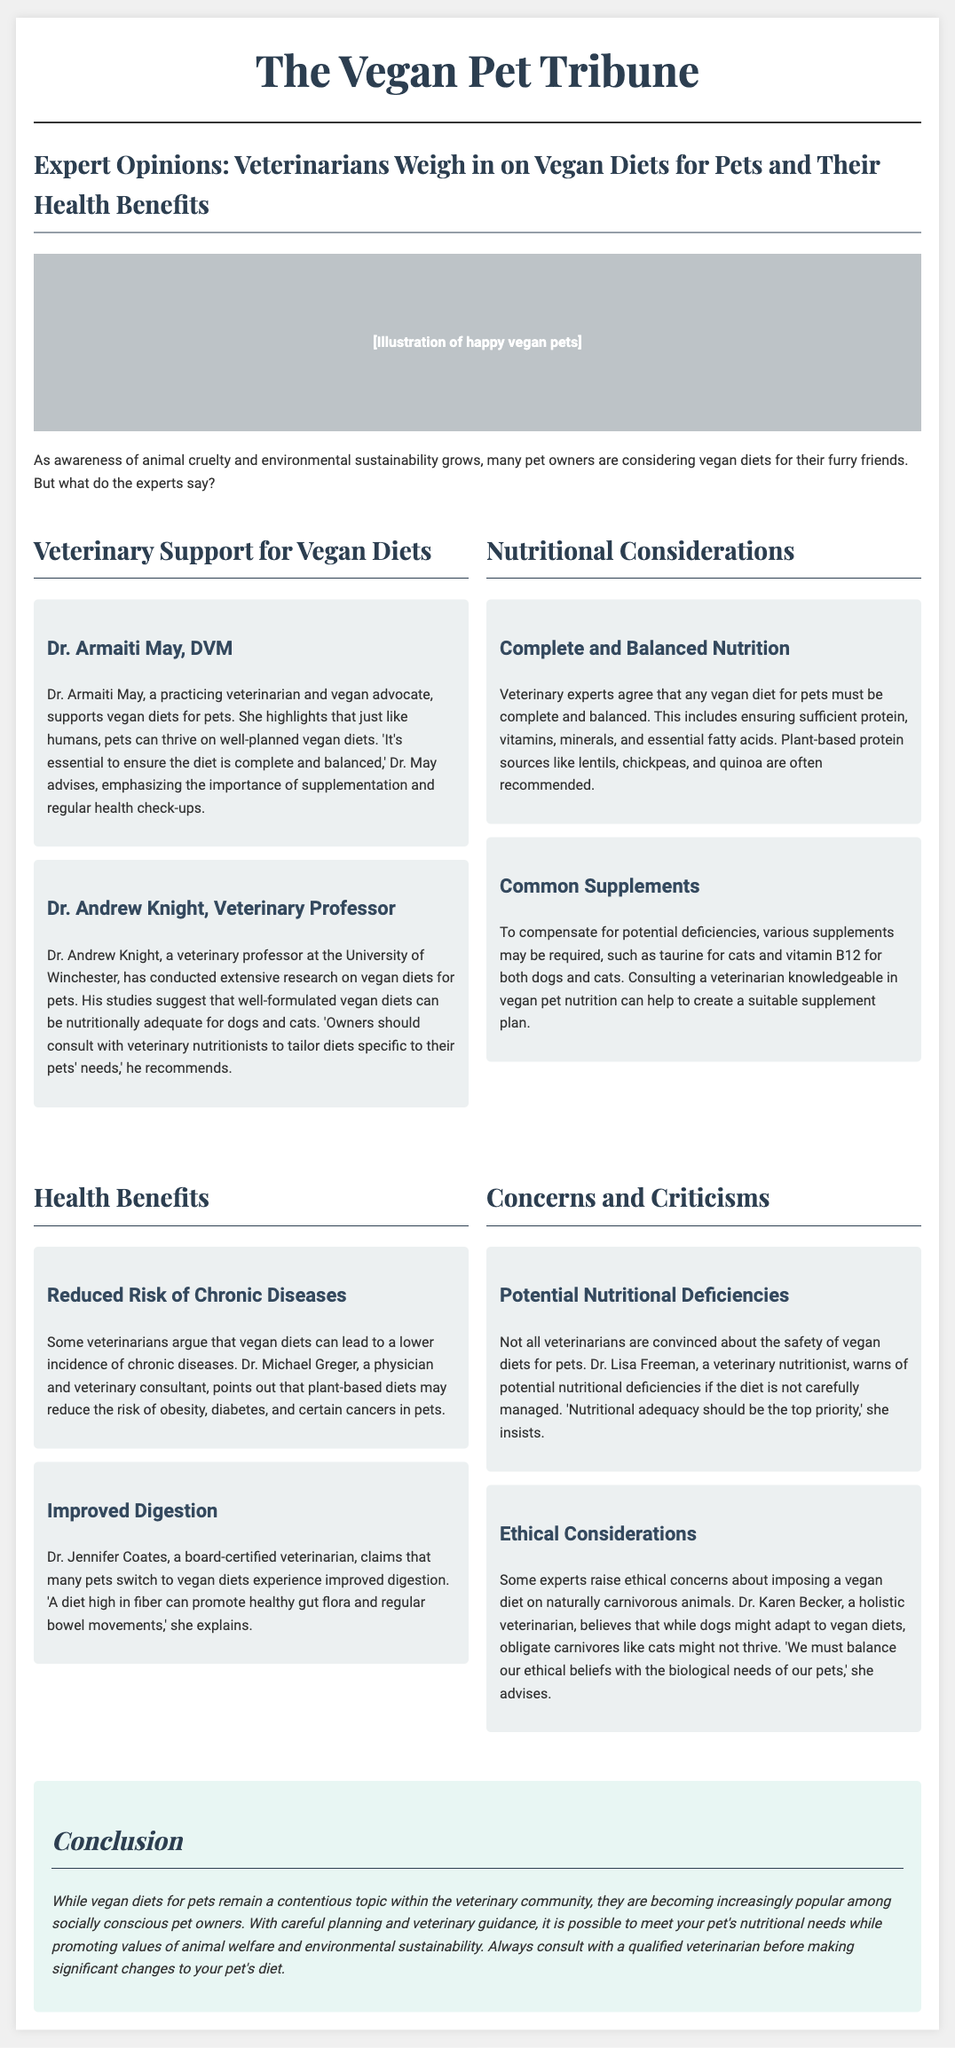What is the name of the veterinarian who supports vegan diets for pets? Dr. Armaiti May is mentioned as a veterinarian and vegan advocate supporting vegan diets for pets.
Answer: Dr. Armaiti May What university is Dr. Andrew Knight associated with? The document states that Dr. Andrew Knight is a veterinary professor at the University of Winchester.
Answer: University of Winchester Which nutrient might be supplemented for cats on a vegan diet? The document mentions that taurine is often a necessary supplement for cats on a vegan diet.
Answer: Taurine What dietary benefit do many pets experience when switching to vegan diets? According to Dr. Jennifer Coates, many pets switching to vegan diets experience improved digestion.
Answer: Improved digestion Who warns about potential nutritional deficiencies in vegan diets for pets? Dr. Lisa Freeman expresses concerns regarding potential nutritional deficiencies in vegan diets.
Answer: Dr. Lisa Freeman What is a common plant-based protein source recommended in vegan diets for pets? The document lists lentils, chickpeas, and quinoa as recommended plant-based protein sources.
Answer: Lentils, chickpeas, and quinoa What ethical concern does Dr. Karen Becker raise regarding vegan diets for pets? Dr. Karen Becker raises the point that while dogs may adapt, obligate carnivores like cats might not thrive on a vegan diet.
Answer: Obligate carnivores like cats What should be prioritized when formulating a vegan diet for pets? The document states that nutritional adequacy should be the top priority when formulating a vegan diet for pets.
Answer: Nutritional adequacy What is the overall conclusion regarding vegan diets for pets? The conclusion mentions that vegan diets for pets, while contentious, can meet nutritional needs with careful planning and veterinary guidance.
Answer: Careful planning and veterinary guidance 